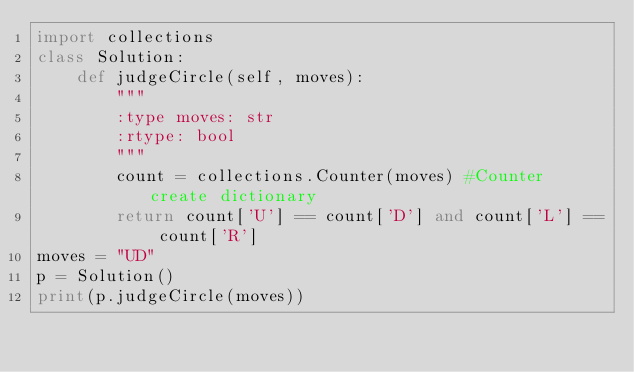Convert code to text. <code><loc_0><loc_0><loc_500><loc_500><_Python_>import collections
class Solution:
    def judgeCircle(self, moves):
        """
        :type moves: str
        :rtype: bool
        """
        count = collections.Counter(moves) #Counter create dictionary
        return count['U'] == count['D'] and count['L'] == count['R']
moves = "UD"
p = Solution()
print(p.judgeCircle(moves))</code> 